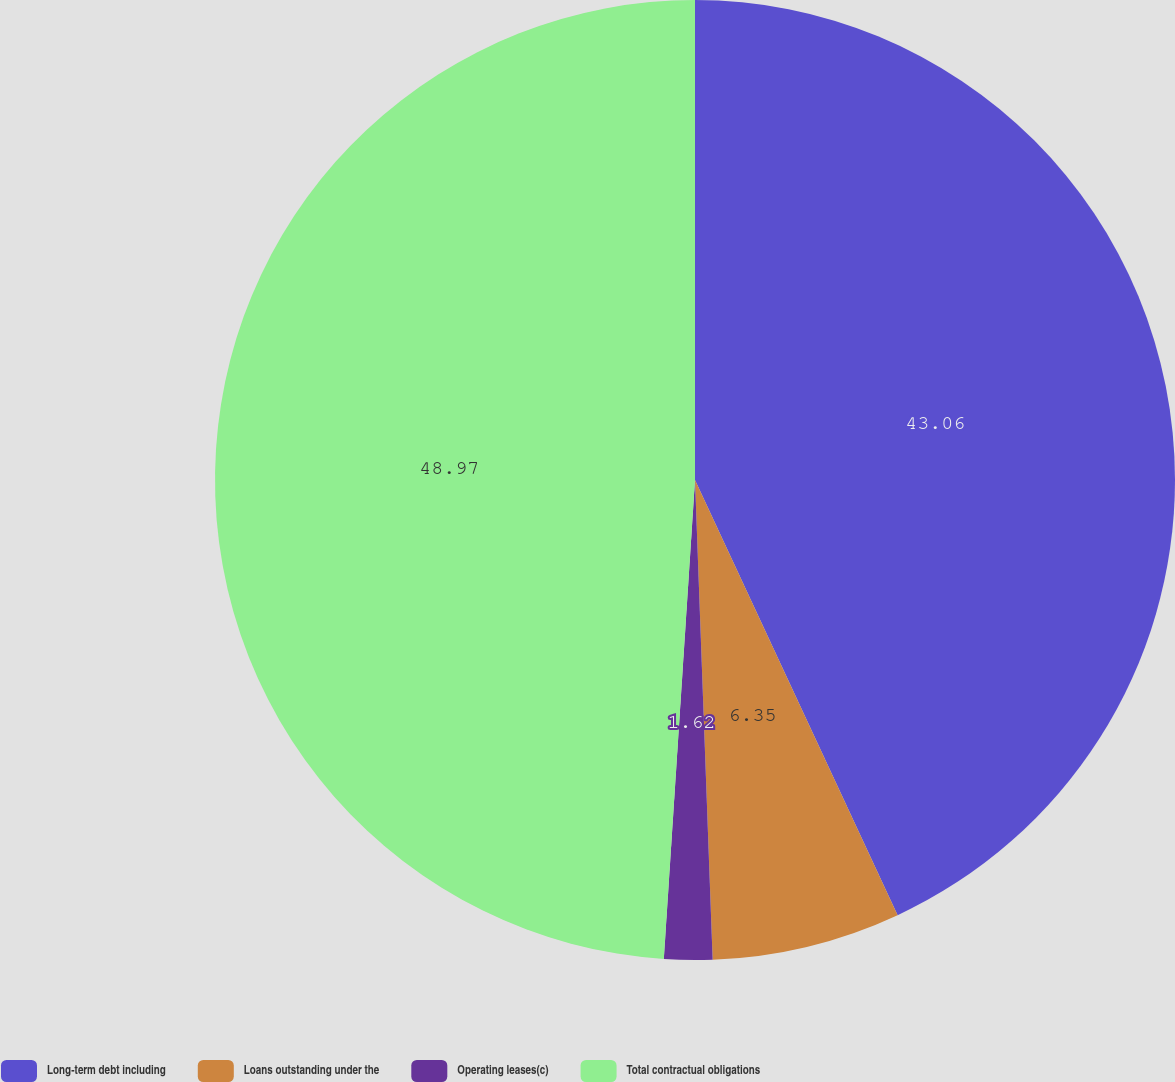Convert chart. <chart><loc_0><loc_0><loc_500><loc_500><pie_chart><fcel>Long-term debt including<fcel>Loans outstanding under the<fcel>Operating leases(c)<fcel>Total contractual obligations<nl><fcel>43.06%<fcel>6.35%<fcel>1.62%<fcel>48.96%<nl></chart> 